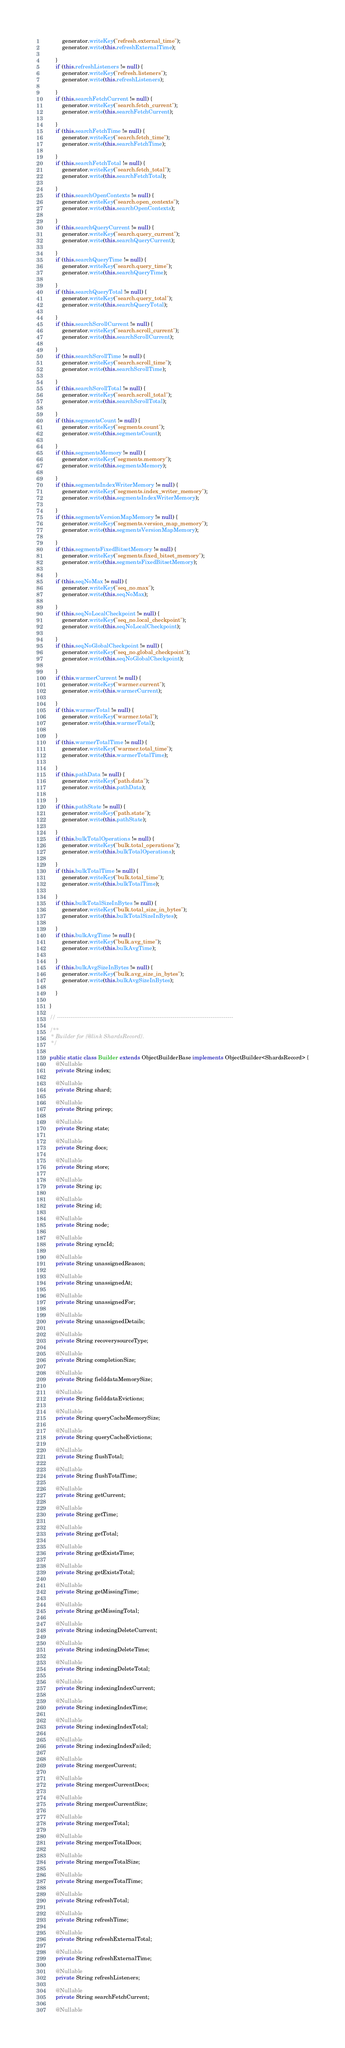Convert code to text. <code><loc_0><loc_0><loc_500><loc_500><_Java_>			generator.writeKey("refresh.external_time");
			generator.write(this.refreshExternalTime);

		}
		if (this.refreshListeners != null) {
			generator.writeKey("refresh.listeners");
			generator.write(this.refreshListeners);

		}
		if (this.searchFetchCurrent != null) {
			generator.writeKey("search.fetch_current");
			generator.write(this.searchFetchCurrent);

		}
		if (this.searchFetchTime != null) {
			generator.writeKey("search.fetch_time");
			generator.write(this.searchFetchTime);

		}
		if (this.searchFetchTotal != null) {
			generator.writeKey("search.fetch_total");
			generator.write(this.searchFetchTotal);

		}
		if (this.searchOpenContexts != null) {
			generator.writeKey("search.open_contexts");
			generator.write(this.searchOpenContexts);

		}
		if (this.searchQueryCurrent != null) {
			generator.writeKey("search.query_current");
			generator.write(this.searchQueryCurrent);

		}
		if (this.searchQueryTime != null) {
			generator.writeKey("search.query_time");
			generator.write(this.searchQueryTime);

		}
		if (this.searchQueryTotal != null) {
			generator.writeKey("search.query_total");
			generator.write(this.searchQueryTotal);

		}
		if (this.searchScrollCurrent != null) {
			generator.writeKey("search.scroll_current");
			generator.write(this.searchScrollCurrent);

		}
		if (this.searchScrollTime != null) {
			generator.writeKey("search.scroll_time");
			generator.write(this.searchScrollTime);

		}
		if (this.searchScrollTotal != null) {
			generator.writeKey("search.scroll_total");
			generator.write(this.searchScrollTotal);

		}
		if (this.segmentsCount != null) {
			generator.writeKey("segments.count");
			generator.write(this.segmentsCount);

		}
		if (this.segmentsMemory != null) {
			generator.writeKey("segments.memory");
			generator.write(this.segmentsMemory);

		}
		if (this.segmentsIndexWriterMemory != null) {
			generator.writeKey("segments.index_writer_memory");
			generator.write(this.segmentsIndexWriterMemory);

		}
		if (this.segmentsVersionMapMemory != null) {
			generator.writeKey("segments.version_map_memory");
			generator.write(this.segmentsVersionMapMemory);

		}
		if (this.segmentsFixedBitsetMemory != null) {
			generator.writeKey("segments.fixed_bitset_memory");
			generator.write(this.segmentsFixedBitsetMemory);

		}
		if (this.seqNoMax != null) {
			generator.writeKey("seq_no.max");
			generator.write(this.seqNoMax);

		}
		if (this.seqNoLocalCheckpoint != null) {
			generator.writeKey("seq_no.local_checkpoint");
			generator.write(this.seqNoLocalCheckpoint);

		}
		if (this.seqNoGlobalCheckpoint != null) {
			generator.writeKey("seq_no.global_checkpoint");
			generator.write(this.seqNoGlobalCheckpoint);

		}
		if (this.warmerCurrent != null) {
			generator.writeKey("warmer.current");
			generator.write(this.warmerCurrent);

		}
		if (this.warmerTotal != null) {
			generator.writeKey("warmer.total");
			generator.write(this.warmerTotal);

		}
		if (this.warmerTotalTime != null) {
			generator.writeKey("warmer.total_time");
			generator.write(this.warmerTotalTime);

		}
		if (this.pathData != null) {
			generator.writeKey("path.data");
			generator.write(this.pathData);

		}
		if (this.pathState != null) {
			generator.writeKey("path.state");
			generator.write(this.pathState);

		}
		if (this.bulkTotalOperations != null) {
			generator.writeKey("bulk.total_operations");
			generator.write(this.bulkTotalOperations);

		}
		if (this.bulkTotalTime != null) {
			generator.writeKey("bulk.total_time");
			generator.write(this.bulkTotalTime);

		}
		if (this.bulkTotalSizeInBytes != null) {
			generator.writeKey("bulk.total_size_in_bytes");
			generator.write(this.bulkTotalSizeInBytes);

		}
		if (this.bulkAvgTime != null) {
			generator.writeKey("bulk.avg_time");
			generator.write(this.bulkAvgTime);

		}
		if (this.bulkAvgSizeInBytes != null) {
			generator.writeKey("bulk.avg_size_in_bytes");
			generator.write(this.bulkAvgSizeInBytes);

		}

	}

	// ---------------------------------------------------------------------------------------------

	/**
	 * Builder for {@link ShardsRecord}.
	 */

	public static class Builder extends ObjectBuilderBase implements ObjectBuilder<ShardsRecord> {
		@Nullable
		private String index;

		@Nullable
		private String shard;

		@Nullable
		private String prirep;

		@Nullable
		private String state;

		@Nullable
		private String docs;

		@Nullable
		private String store;

		@Nullable
		private String ip;

		@Nullable
		private String id;

		@Nullable
		private String node;

		@Nullable
		private String syncId;

		@Nullable
		private String unassignedReason;

		@Nullable
		private String unassignedAt;

		@Nullable
		private String unassignedFor;

		@Nullable
		private String unassignedDetails;

		@Nullable
		private String recoverysourceType;

		@Nullable
		private String completionSize;

		@Nullable
		private String fielddataMemorySize;

		@Nullable
		private String fielddataEvictions;

		@Nullable
		private String queryCacheMemorySize;

		@Nullable
		private String queryCacheEvictions;

		@Nullable
		private String flushTotal;

		@Nullable
		private String flushTotalTime;

		@Nullable
		private String getCurrent;

		@Nullable
		private String getTime;

		@Nullable
		private String getTotal;

		@Nullable
		private String getExistsTime;

		@Nullable
		private String getExistsTotal;

		@Nullable
		private String getMissingTime;

		@Nullable
		private String getMissingTotal;

		@Nullable
		private String indexingDeleteCurrent;

		@Nullable
		private String indexingDeleteTime;

		@Nullable
		private String indexingDeleteTotal;

		@Nullable
		private String indexingIndexCurrent;

		@Nullable
		private String indexingIndexTime;

		@Nullable
		private String indexingIndexTotal;

		@Nullable
		private String indexingIndexFailed;

		@Nullable
		private String mergesCurrent;

		@Nullable
		private String mergesCurrentDocs;

		@Nullable
		private String mergesCurrentSize;

		@Nullable
		private String mergesTotal;

		@Nullable
		private String mergesTotalDocs;

		@Nullable
		private String mergesTotalSize;

		@Nullable
		private String mergesTotalTime;

		@Nullable
		private String refreshTotal;

		@Nullable
		private String refreshTime;

		@Nullable
		private String refreshExternalTotal;

		@Nullable
		private String refreshExternalTime;

		@Nullable
		private String refreshListeners;

		@Nullable
		private String searchFetchCurrent;

		@Nullable</code> 